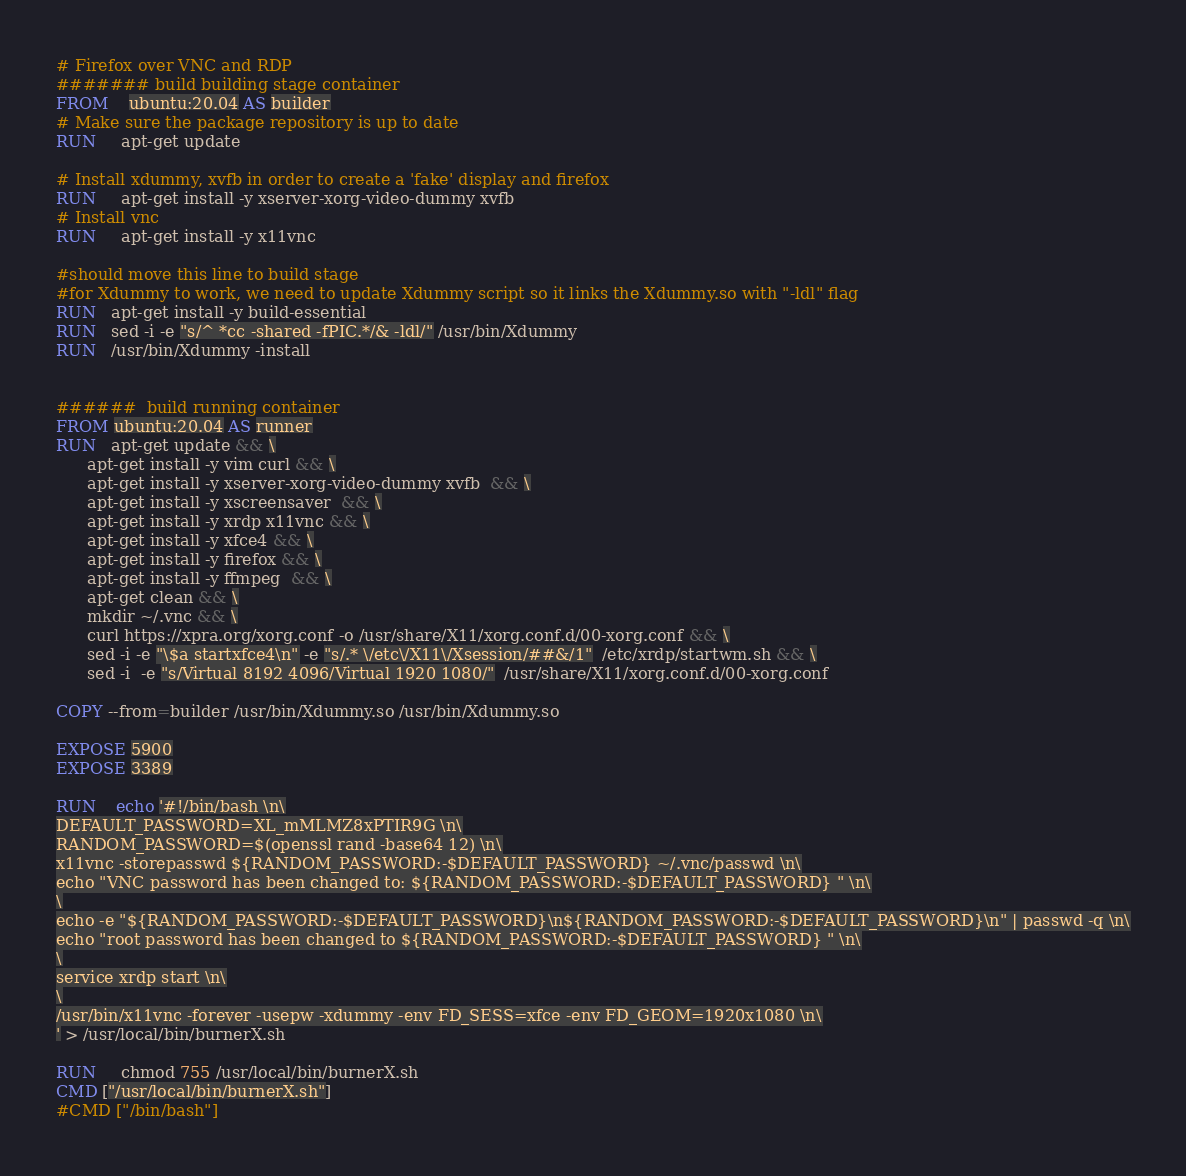<code> <loc_0><loc_0><loc_500><loc_500><_Dockerfile_># Firefox over VNC and RDP
####### build building stage container
FROM    ubuntu:20.04 AS builder
# Make sure the package repository is up to date
RUN     apt-get update 

# Install xdummy, xvfb in order to create a 'fake' display and firefox
RUN     apt-get install -y xserver-xorg-video-dummy xvfb
# Install vnc
RUN     apt-get install -y x11vnc 

#should move this line to build stage
#for Xdummy to work, we need to update Xdummy script so it links the Xdummy.so with "-ldl" flag
RUN   apt-get install -y build-essential
RUN   sed -i -e "s/^ *cc -shared -fPIC.*/& -ldl/" /usr/bin/Xdummy
RUN   /usr/bin/Xdummy -install


######  build running container
FROM ubuntu:20.04 AS runner
RUN   apt-get update && \
      apt-get install -y vim curl && \
      apt-get install -y xserver-xorg-video-dummy xvfb  && \
      apt-get install -y xscreensaver  && \
      apt-get install -y xrdp x11vnc && \
      apt-get install -y xfce4 && \
      apt-get install -y firefox && \
      apt-get install -y ffmpeg  && \
      apt-get clean && \
      mkdir ~/.vnc && \
      curl https://xpra.org/xorg.conf -o /usr/share/X11/xorg.conf.d/00-xorg.conf && \
      sed -i -e "\$a startxfce4\n" -e "s/.* \/etc\/X11\/Xsession/##&/1"  /etc/xrdp/startwm.sh && \
      sed -i  -e "s/Virtual 8192 4096/Virtual 1920 1080/"  /usr/share/X11/xorg.conf.d/00-xorg.conf

COPY --from=builder /usr/bin/Xdummy.so /usr/bin/Xdummy.so

EXPOSE 5900
EXPOSE 3389

RUN    echo '#!/bin/bash \n\
DEFAULT_PASSWORD=XL_mMLMZ8xPTIR9G \n\
RANDOM_PASSWORD=$(openssl rand -base64 12) \n\
x11vnc -storepasswd ${RANDOM_PASSWORD:-$DEFAULT_PASSWORD} ~/.vnc/passwd \n\
echo "VNC password has been changed to: ${RANDOM_PASSWORD:-$DEFAULT_PASSWORD} " \n\
\
echo -e "${RANDOM_PASSWORD:-$DEFAULT_PASSWORD}\n${RANDOM_PASSWORD:-$DEFAULT_PASSWORD}\n" | passwd -q \n\
echo "root password has been changed to ${RANDOM_PASSWORD:-$DEFAULT_PASSWORD} " \n\
\
service xrdp start \n\
\
/usr/bin/x11vnc -forever -usepw -xdummy -env FD_SESS=xfce -env FD_GEOM=1920x1080 \n\
' > /usr/local/bin/burnerX.sh

RUN     chmod 755 /usr/local/bin/burnerX.sh
CMD ["/usr/local/bin/burnerX.sh"]
#CMD ["/bin/bash"]

</code> 